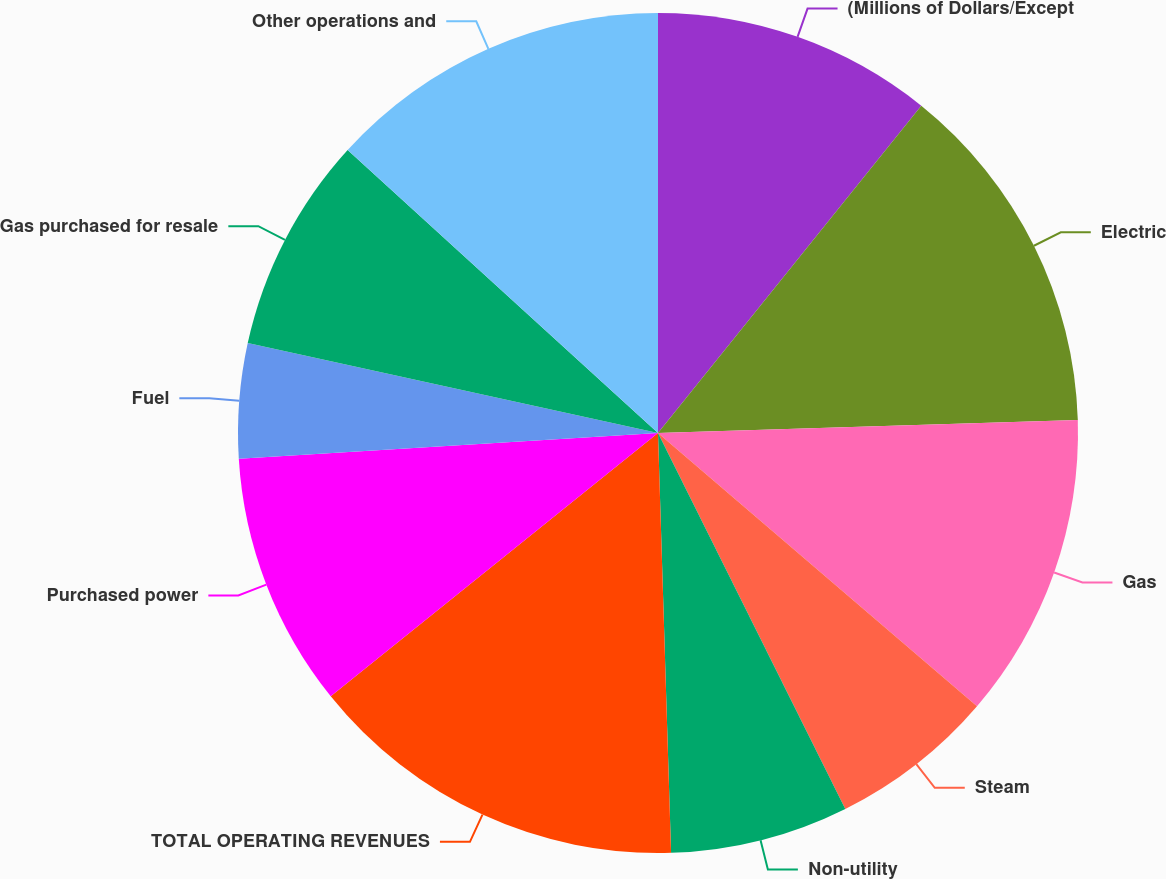Convert chart to OTSL. <chart><loc_0><loc_0><loc_500><loc_500><pie_chart><fcel>(Millions of Dollars/Except<fcel>Electric<fcel>Gas<fcel>Steam<fcel>Non-utility<fcel>TOTAL OPERATING REVENUES<fcel>Purchased power<fcel>Fuel<fcel>Gas purchased for resale<fcel>Other operations and<nl><fcel>10.78%<fcel>13.72%<fcel>11.76%<fcel>6.37%<fcel>6.86%<fcel>14.71%<fcel>9.8%<fcel>4.41%<fcel>8.33%<fcel>13.23%<nl></chart> 